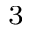Convert formula to latex. <formula><loc_0><loc_0><loc_500><loc_500>^ { 3 }</formula> 